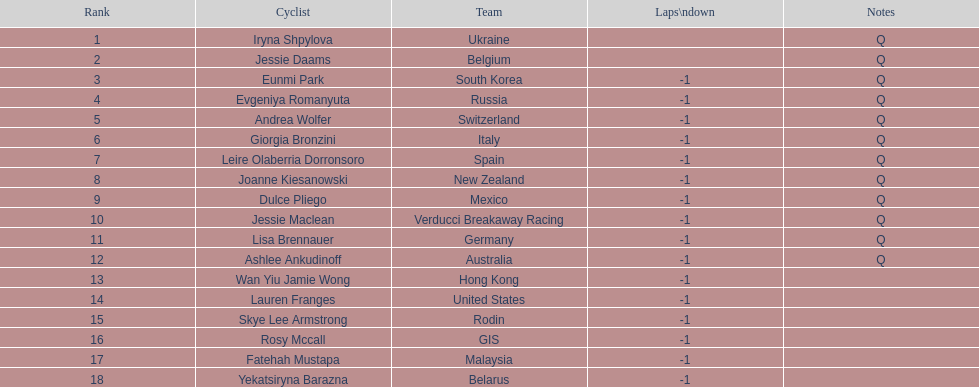How many successive notes are there? 12. 